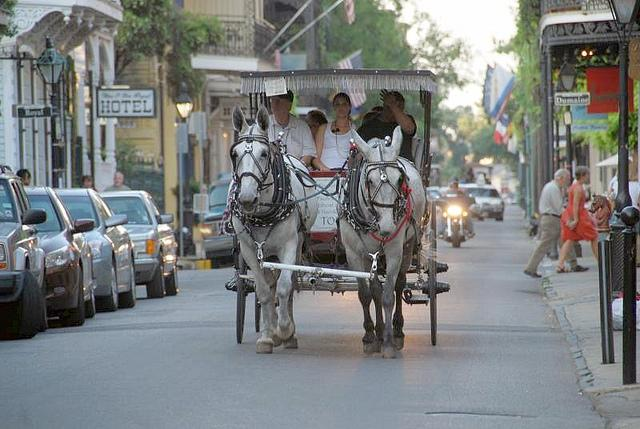Why are there horses in front of the carriage? to pull 